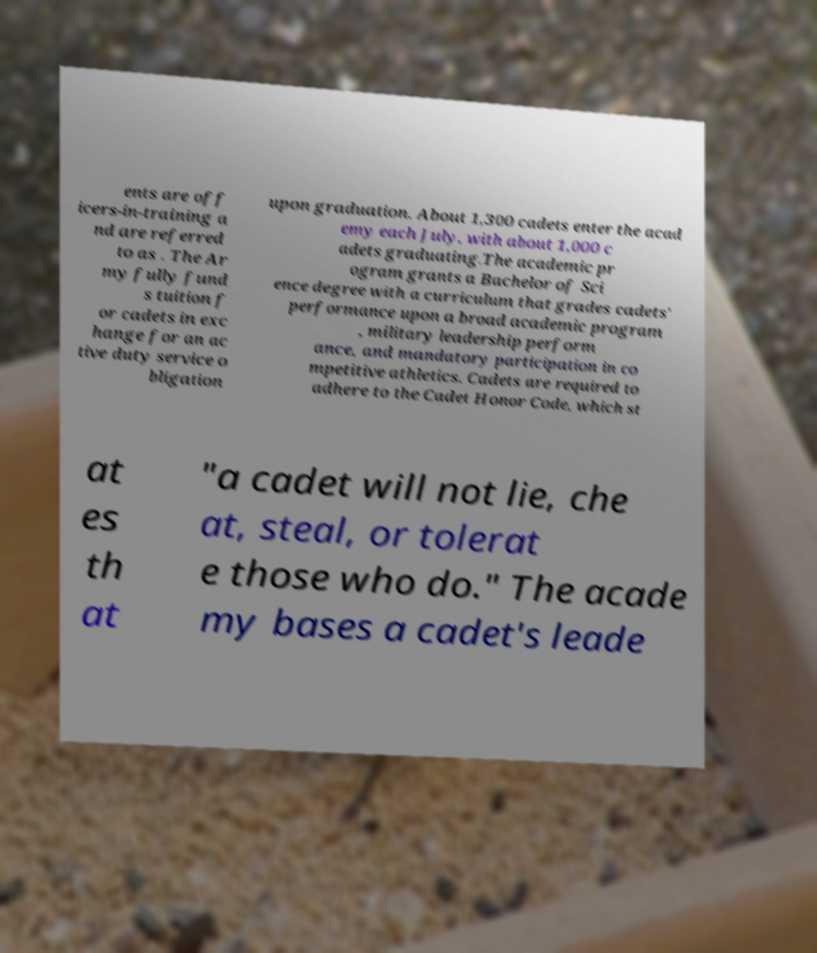For documentation purposes, I need the text within this image transcribed. Could you provide that? ents are off icers-in-training a nd are referred to as . The Ar my fully fund s tuition f or cadets in exc hange for an ac tive duty service o bligation upon graduation. About 1,300 cadets enter the acad emy each July, with about 1,000 c adets graduating.The academic pr ogram grants a Bachelor of Sci ence degree with a curriculum that grades cadets' performance upon a broad academic program , military leadership perform ance, and mandatory participation in co mpetitive athletics. Cadets are required to adhere to the Cadet Honor Code, which st at es th at "a cadet will not lie, che at, steal, or tolerat e those who do." The acade my bases a cadet's leade 